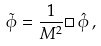<formula> <loc_0><loc_0><loc_500><loc_500>\tilde { \phi } = \frac { 1 } { M ^ { 2 } } \Box \, \hat { \phi } \, ,</formula> 